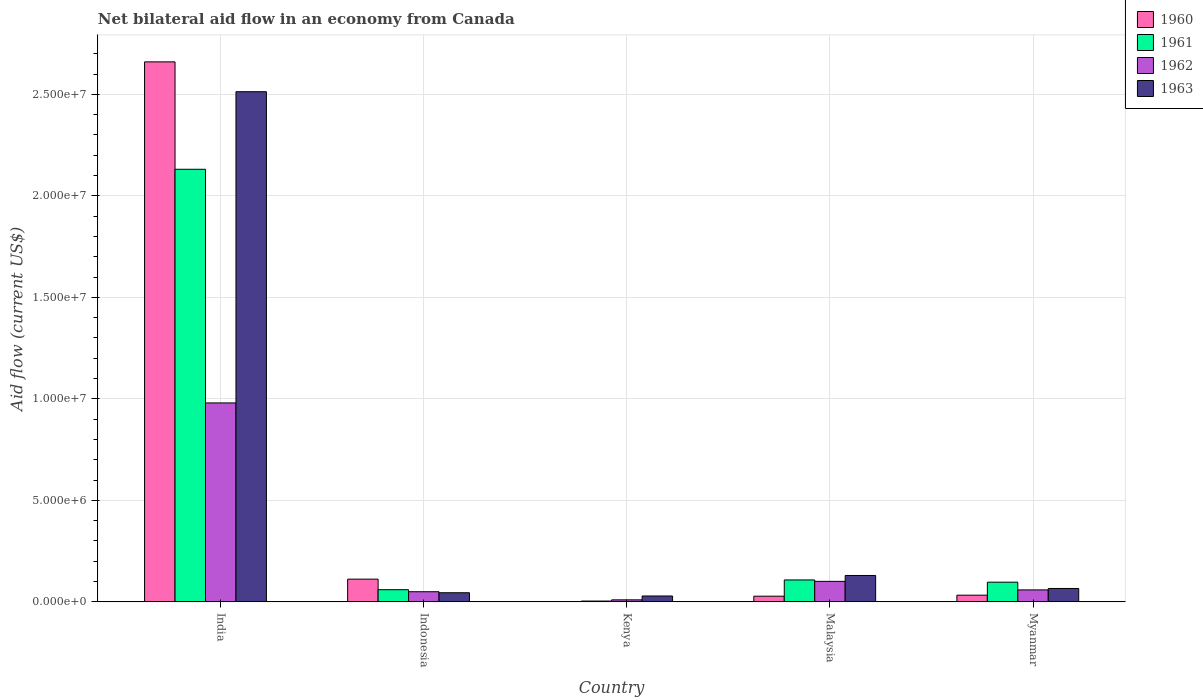How many different coloured bars are there?
Your response must be concise. 4. How many groups of bars are there?
Ensure brevity in your answer.  5. Are the number of bars per tick equal to the number of legend labels?
Offer a very short reply. Yes. Are the number of bars on each tick of the X-axis equal?
Provide a short and direct response. Yes. What is the label of the 5th group of bars from the left?
Your answer should be compact. Myanmar. What is the net bilateral aid flow in 1961 in India?
Provide a short and direct response. 2.13e+07. Across all countries, what is the maximum net bilateral aid flow in 1963?
Ensure brevity in your answer.  2.51e+07. In which country was the net bilateral aid flow in 1962 maximum?
Keep it short and to the point. India. In which country was the net bilateral aid flow in 1963 minimum?
Provide a short and direct response. Kenya. What is the total net bilateral aid flow in 1963 in the graph?
Ensure brevity in your answer.  2.78e+07. What is the difference between the net bilateral aid flow in 1963 in Kenya and the net bilateral aid flow in 1962 in Malaysia?
Your response must be concise. -7.20e+05. What is the average net bilateral aid flow in 1961 per country?
Make the answer very short. 4.80e+06. What is the difference between the net bilateral aid flow of/in 1960 and net bilateral aid flow of/in 1961 in Indonesia?
Make the answer very short. 5.20e+05. What is the ratio of the net bilateral aid flow in 1960 in Malaysia to that in Myanmar?
Make the answer very short. 0.85. Is the net bilateral aid flow in 1962 in Malaysia less than that in Myanmar?
Give a very brief answer. No. What is the difference between the highest and the second highest net bilateral aid flow in 1963?
Provide a short and direct response. 2.38e+07. What is the difference between the highest and the lowest net bilateral aid flow in 1962?
Ensure brevity in your answer.  9.70e+06. In how many countries, is the net bilateral aid flow in 1960 greater than the average net bilateral aid flow in 1960 taken over all countries?
Keep it short and to the point. 1. Is it the case that in every country, the sum of the net bilateral aid flow in 1960 and net bilateral aid flow in 1962 is greater than the sum of net bilateral aid flow in 1963 and net bilateral aid flow in 1961?
Your answer should be very brief. No. What does the 4th bar from the left in Malaysia represents?
Offer a terse response. 1963. Is it the case that in every country, the sum of the net bilateral aid flow in 1963 and net bilateral aid flow in 1961 is greater than the net bilateral aid flow in 1962?
Your answer should be very brief. Yes. Are all the bars in the graph horizontal?
Your answer should be compact. No. How many countries are there in the graph?
Make the answer very short. 5. What is the difference between two consecutive major ticks on the Y-axis?
Give a very brief answer. 5.00e+06. Are the values on the major ticks of Y-axis written in scientific E-notation?
Offer a very short reply. Yes. Does the graph contain any zero values?
Offer a very short reply. No. Where does the legend appear in the graph?
Offer a terse response. Top right. How many legend labels are there?
Offer a very short reply. 4. What is the title of the graph?
Make the answer very short. Net bilateral aid flow in an economy from Canada. What is the label or title of the X-axis?
Provide a succinct answer. Country. What is the label or title of the Y-axis?
Provide a succinct answer. Aid flow (current US$). What is the Aid flow (current US$) in 1960 in India?
Your answer should be very brief. 2.66e+07. What is the Aid flow (current US$) in 1961 in India?
Offer a terse response. 2.13e+07. What is the Aid flow (current US$) of 1962 in India?
Provide a short and direct response. 9.80e+06. What is the Aid flow (current US$) of 1963 in India?
Ensure brevity in your answer.  2.51e+07. What is the Aid flow (current US$) in 1960 in Indonesia?
Offer a terse response. 1.12e+06. What is the Aid flow (current US$) of 1963 in Indonesia?
Your response must be concise. 4.50e+05. What is the Aid flow (current US$) of 1962 in Kenya?
Make the answer very short. 1.00e+05. What is the Aid flow (current US$) of 1963 in Kenya?
Offer a very short reply. 2.90e+05. What is the Aid flow (current US$) of 1960 in Malaysia?
Offer a very short reply. 2.80e+05. What is the Aid flow (current US$) of 1961 in Malaysia?
Make the answer very short. 1.08e+06. What is the Aid flow (current US$) of 1962 in Malaysia?
Offer a terse response. 1.01e+06. What is the Aid flow (current US$) of 1963 in Malaysia?
Offer a very short reply. 1.30e+06. What is the Aid flow (current US$) in 1961 in Myanmar?
Make the answer very short. 9.70e+05. What is the Aid flow (current US$) in 1962 in Myanmar?
Offer a terse response. 5.90e+05. What is the Aid flow (current US$) of 1963 in Myanmar?
Provide a succinct answer. 6.60e+05. Across all countries, what is the maximum Aid flow (current US$) of 1960?
Your response must be concise. 2.66e+07. Across all countries, what is the maximum Aid flow (current US$) of 1961?
Your answer should be very brief. 2.13e+07. Across all countries, what is the maximum Aid flow (current US$) of 1962?
Make the answer very short. 9.80e+06. Across all countries, what is the maximum Aid flow (current US$) in 1963?
Make the answer very short. 2.51e+07. Across all countries, what is the minimum Aid flow (current US$) in 1960?
Your answer should be very brief. 10000. Across all countries, what is the minimum Aid flow (current US$) in 1961?
Provide a short and direct response. 4.00e+04. Across all countries, what is the minimum Aid flow (current US$) of 1962?
Offer a very short reply. 1.00e+05. What is the total Aid flow (current US$) of 1960 in the graph?
Your answer should be compact. 2.83e+07. What is the total Aid flow (current US$) in 1961 in the graph?
Provide a succinct answer. 2.40e+07. What is the total Aid flow (current US$) in 1962 in the graph?
Your answer should be compact. 1.20e+07. What is the total Aid flow (current US$) of 1963 in the graph?
Make the answer very short. 2.78e+07. What is the difference between the Aid flow (current US$) in 1960 in India and that in Indonesia?
Your answer should be compact. 2.55e+07. What is the difference between the Aid flow (current US$) in 1961 in India and that in Indonesia?
Provide a succinct answer. 2.07e+07. What is the difference between the Aid flow (current US$) in 1962 in India and that in Indonesia?
Ensure brevity in your answer.  9.30e+06. What is the difference between the Aid flow (current US$) of 1963 in India and that in Indonesia?
Keep it short and to the point. 2.47e+07. What is the difference between the Aid flow (current US$) of 1960 in India and that in Kenya?
Ensure brevity in your answer.  2.66e+07. What is the difference between the Aid flow (current US$) of 1961 in India and that in Kenya?
Your response must be concise. 2.13e+07. What is the difference between the Aid flow (current US$) of 1962 in India and that in Kenya?
Ensure brevity in your answer.  9.70e+06. What is the difference between the Aid flow (current US$) of 1963 in India and that in Kenya?
Your answer should be very brief. 2.48e+07. What is the difference between the Aid flow (current US$) of 1960 in India and that in Malaysia?
Ensure brevity in your answer.  2.63e+07. What is the difference between the Aid flow (current US$) in 1961 in India and that in Malaysia?
Offer a terse response. 2.02e+07. What is the difference between the Aid flow (current US$) in 1962 in India and that in Malaysia?
Give a very brief answer. 8.79e+06. What is the difference between the Aid flow (current US$) in 1963 in India and that in Malaysia?
Ensure brevity in your answer.  2.38e+07. What is the difference between the Aid flow (current US$) in 1960 in India and that in Myanmar?
Offer a very short reply. 2.63e+07. What is the difference between the Aid flow (current US$) of 1961 in India and that in Myanmar?
Provide a short and direct response. 2.03e+07. What is the difference between the Aid flow (current US$) of 1962 in India and that in Myanmar?
Keep it short and to the point. 9.21e+06. What is the difference between the Aid flow (current US$) of 1963 in India and that in Myanmar?
Your response must be concise. 2.45e+07. What is the difference between the Aid flow (current US$) of 1960 in Indonesia and that in Kenya?
Provide a succinct answer. 1.11e+06. What is the difference between the Aid flow (current US$) in 1961 in Indonesia and that in Kenya?
Offer a very short reply. 5.60e+05. What is the difference between the Aid flow (current US$) of 1962 in Indonesia and that in Kenya?
Offer a very short reply. 4.00e+05. What is the difference between the Aid flow (current US$) of 1960 in Indonesia and that in Malaysia?
Provide a succinct answer. 8.40e+05. What is the difference between the Aid flow (current US$) of 1961 in Indonesia and that in Malaysia?
Provide a short and direct response. -4.80e+05. What is the difference between the Aid flow (current US$) in 1962 in Indonesia and that in Malaysia?
Give a very brief answer. -5.10e+05. What is the difference between the Aid flow (current US$) of 1963 in Indonesia and that in Malaysia?
Make the answer very short. -8.50e+05. What is the difference between the Aid flow (current US$) of 1960 in Indonesia and that in Myanmar?
Provide a succinct answer. 7.90e+05. What is the difference between the Aid flow (current US$) in 1961 in Indonesia and that in Myanmar?
Your response must be concise. -3.70e+05. What is the difference between the Aid flow (current US$) of 1962 in Indonesia and that in Myanmar?
Provide a short and direct response. -9.00e+04. What is the difference between the Aid flow (current US$) of 1961 in Kenya and that in Malaysia?
Provide a short and direct response. -1.04e+06. What is the difference between the Aid flow (current US$) in 1962 in Kenya and that in Malaysia?
Your response must be concise. -9.10e+05. What is the difference between the Aid flow (current US$) in 1963 in Kenya and that in Malaysia?
Provide a short and direct response. -1.01e+06. What is the difference between the Aid flow (current US$) in 1960 in Kenya and that in Myanmar?
Your response must be concise. -3.20e+05. What is the difference between the Aid flow (current US$) of 1961 in Kenya and that in Myanmar?
Offer a terse response. -9.30e+05. What is the difference between the Aid flow (current US$) of 1962 in Kenya and that in Myanmar?
Offer a very short reply. -4.90e+05. What is the difference between the Aid flow (current US$) in 1963 in Kenya and that in Myanmar?
Give a very brief answer. -3.70e+05. What is the difference between the Aid flow (current US$) in 1962 in Malaysia and that in Myanmar?
Make the answer very short. 4.20e+05. What is the difference between the Aid flow (current US$) of 1963 in Malaysia and that in Myanmar?
Provide a short and direct response. 6.40e+05. What is the difference between the Aid flow (current US$) of 1960 in India and the Aid flow (current US$) of 1961 in Indonesia?
Ensure brevity in your answer.  2.60e+07. What is the difference between the Aid flow (current US$) of 1960 in India and the Aid flow (current US$) of 1962 in Indonesia?
Give a very brief answer. 2.61e+07. What is the difference between the Aid flow (current US$) of 1960 in India and the Aid flow (current US$) of 1963 in Indonesia?
Offer a very short reply. 2.62e+07. What is the difference between the Aid flow (current US$) of 1961 in India and the Aid flow (current US$) of 1962 in Indonesia?
Provide a succinct answer. 2.08e+07. What is the difference between the Aid flow (current US$) in 1961 in India and the Aid flow (current US$) in 1963 in Indonesia?
Your response must be concise. 2.09e+07. What is the difference between the Aid flow (current US$) in 1962 in India and the Aid flow (current US$) in 1963 in Indonesia?
Your response must be concise. 9.35e+06. What is the difference between the Aid flow (current US$) of 1960 in India and the Aid flow (current US$) of 1961 in Kenya?
Your answer should be compact. 2.66e+07. What is the difference between the Aid flow (current US$) of 1960 in India and the Aid flow (current US$) of 1962 in Kenya?
Give a very brief answer. 2.65e+07. What is the difference between the Aid flow (current US$) in 1960 in India and the Aid flow (current US$) in 1963 in Kenya?
Provide a short and direct response. 2.63e+07. What is the difference between the Aid flow (current US$) of 1961 in India and the Aid flow (current US$) of 1962 in Kenya?
Offer a terse response. 2.12e+07. What is the difference between the Aid flow (current US$) of 1961 in India and the Aid flow (current US$) of 1963 in Kenya?
Give a very brief answer. 2.10e+07. What is the difference between the Aid flow (current US$) in 1962 in India and the Aid flow (current US$) in 1963 in Kenya?
Offer a terse response. 9.51e+06. What is the difference between the Aid flow (current US$) of 1960 in India and the Aid flow (current US$) of 1961 in Malaysia?
Ensure brevity in your answer.  2.55e+07. What is the difference between the Aid flow (current US$) in 1960 in India and the Aid flow (current US$) in 1962 in Malaysia?
Your answer should be very brief. 2.56e+07. What is the difference between the Aid flow (current US$) of 1960 in India and the Aid flow (current US$) of 1963 in Malaysia?
Ensure brevity in your answer.  2.53e+07. What is the difference between the Aid flow (current US$) of 1961 in India and the Aid flow (current US$) of 1962 in Malaysia?
Provide a short and direct response. 2.03e+07. What is the difference between the Aid flow (current US$) of 1961 in India and the Aid flow (current US$) of 1963 in Malaysia?
Provide a short and direct response. 2.00e+07. What is the difference between the Aid flow (current US$) in 1962 in India and the Aid flow (current US$) in 1963 in Malaysia?
Ensure brevity in your answer.  8.50e+06. What is the difference between the Aid flow (current US$) in 1960 in India and the Aid flow (current US$) in 1961 in Myanmar?
Ensure brevity in your answer.  2.56e+07. What is the difference between the Aid flow (current US$) of 1960 in India and the Aid flow (current US$) of 1962 in Myanmar?
Your answer should be compact. 2.60e+07. What is the difference between the Aid flow (current US$) of 1960 in India and the Aid flow (current US$) of 1963 in Myanmar?
Provide a short and direct response. 2.59e+07. What is the difference between the Aid flow (current US$) in 1961 in India and the Aid flow (current US$) in 1962 in Myanmar?
Keep it short and to the point. 2.07e+07. What is the difference between the Aid flow (current US$) in 1961 in India and the Aid flow (current US$) in 1963 in Myanmar?
Keep it short and to the point. 2.06e+07. What is the difference between the Aid flow (current US$) in 1962 in India and the Aid flow (current US$) in 1963 in Myanmar?
Your answer should be very brief. 9.14e+06. What is the difference between the Aid flow (current US$) in 1960 in Indonesia and the Aid flow (current US$) in 1961 in Kenya?
Provide a succinct answer. 1.08e+06. What is the difference between the Aid flow (current US$) in 1960 in Indonesia and the Aid flow (current US$) in 1962 in Kenya?
Make the answer very short. 1.02e+06. What is the difference between the Aid flow (current US$) of 1960 in Indonesia and the Aid flow (current US$) of 1963 in Kenya?
Offer a very short reply. 8.30e+05. What is the difference between the Aid flow (current US$) in 1961 in Indonesia and the Aid flow (current US$) in 1962 in Kenya?
Your response must be concise. 5.00e+05. What is the difference between the Aid flow (current US$) in 1962 in Indonesia and the Aid flow (current US$) in 1963 in Kenya?
Offer a very short reply. 2.10e+05. What is the difference between the Aid flow (current US$) in 1960 in Indonesia and the Aid flow (current US$) in 1962 in Malaysia?
Provide a succinct answer. 1.10e+05. What is the difference between the Aid flow (current US$) in 1961 in Indonesia and the Aid flow (current US$) in 1962 in Malaysia?
Provide a succinct answer. -4.10e+05. What is the difference between the Aid flow (current US$) of 1961 in Indonesia and the Aid flow (current US$) of 1963 in Malaysia?
Ensure brevity in your answer.  -7.00e+05. What is the difference between the Aid flow (current US$) of 1962 in Indonesia and the Aid flow (current US$) of 1963 in Malaysia?
Your response must be concise. -8.00e+05. What is the difference between the Aid flow (current US$) in 1960 in Indonesia and the Aid flow (current US$) in 1961 in Myanmar?
Provide a short and direct response. 1.50e+05. What is the difference between the Aid flow (current US$) in 1960 in Indonesia and the Aid flow (current US$) in 1962 in Myanmar?
Offer a terse response. 5.30e+05. What is the difference between the Aid flow (current US$) of 1962 in Indonesia and the Aid flow (current US$) of 1963 in Myanmar?
Give a very brief answer. -1.60e+05. What is the difference between the Aid flow (current US$) of 1960 in Kenya and the Aid flow (current US$) of 1961 in Malaysia?
Keep it short and to the point. -1.07e+06. What is the difference between the Aid flow (current US$) in 1960 in Kenya and the Aid flow (current US$) in 1963 in Malaysia?
Provide a short and direct response. -1.29e+06. What is the difference between the Aid flow (current US$) of 1961 in Kenya and the Aid flow (current US$) of 1962 in Malaysia?
Ensure brevity in your answer.  -9.70e+05. What is the difference between the Aid flow (current US$) of 1961 in Kenya and the Aid flow (current US$) of 1963 in Malaysia?
Provide a succinct answer. -1.26e+06. What is the difference between the Aid flow (current US$) in 1962 in Kenya and the Aid flow (current US$) in 1963 in Malaysia?
Ensure brevity in your answer.  -1.20e+06. What is the difference between the Aid flow (current US$) in 1960 in Kenya and the Aid flow (current US$) in 1961 in Myanmar?
Provide a short and direct response. -9.60e+05. What is the difference between the Aid flow (current US$) in 1960 in Kenya and the Aid flow (current US$) in 1962 in Myanmar?
Keep it short and to the point. -5.80e+05. What is the difference between the Aid flow (current US$) in 1960 in Kenya and the Aid flow (current US$) in 1963 in Myanmar?
Offer a very short reply. -6.50e+05. What is the difference between the Aid flow (current US$) in 1961 in Kenya and the Aid flow (current US$) in 1962 in Myanmar?
Keep it short and to the point. -5.50e+05. What is the difference between the Aid flow (current US$) of 1961 in Kenya and the Aid flow (current US$) of 1963 in Myanmar?
Give a very brief answer. -6.20e+05. What is the difference between the Aid flow (current US$) of 1962 in Kenya and the Aid flow (current US$) of 1963 in Myanmar?
Your answer should be very brief. -5.60e+05. What is the difference between the Aid flow (current US$) in 1960 in Malaysia and the Aid flow (current US$) in 1961 in Myanmar?
Your answer should be very brief. -6.90e+05. What is the difference between the Aid flow (current US$) in 1960 in Malaysia and the Aid flow (current US$) in 1962 in Myanmar?
Your response must be concise. -3.10e+05. What is the difference between the Aid flow (current US$) in 1960 in Malaysia and the Aid flow (current US$) in 1963 in Myanmar?
Your answer should be compact. -3.80e+05. What is the difference between the Aid flow (current US$) in 1961 in Malaysia and the Aid flow (current US$) in 1963 in Myanmar?
Make the answer very short. 4.20e+05. What is the difference between the Aid flow (current US$) of 1962 in Malaysia and the Aid flow (current US$) of 1963 in Myanmar?
Your response must be concise. 3.50e+05. What is the average Aid flow (current US$) in 1960 per country?
Your answer should be compact. 5.67e+06. What is the average Aid flow (current US$) in 1961 per country?
Make the answer very short. 4.80e+06. What is the average Aid flow (current US$) of 1962 per country?
Provide a succinct answer. 2.40e+06. What is the average Aid flow (current US$) in 1963 per country?
Give a very brief answer. 5.57e+06. What is the difference between the Aid flow (current US$) of 1960 and Aid flow (current US$) of 1961 in India?
Your answer should be compact. 5.29e+06. What is the difference between the Aid flow (current US$) in 1960 and Aid flow (current US$) in 1962 in India?
Provide a succinct answer. 1.68e+07. What is the difference between the Aid flow (current US$) of 1960 and Aid flow (current US$) of 1963 in India?
Offer a very short reply. 1.47e+06. What is the difference between the Aid flow (current US$) of 1961 and Aid flow (current US$) of 1962 in India?
Provide a short and direct response. 1.15e+07. What is the difference between the Aid flow (current US$) of 1961 and Aid flow (current US$) of 1963 in India?
Ensure brevity in your answer.  -3.82e+06. What is the difference between the Aid flow (current US$) in 1962 and Aid flow (current US$) in 1963 in India?
Make the answer very short. -1.53e+07. What is the difference between the Aid flow (current US$) in 1960 and Aid flow (current US$) in 1961 in Indonesia?
Offer a very short reply. 5.20e+05. What is the difference between the Aid flow (current US$) of 1960 and Aid flow (current US$) of 1962 in Indonesia?
Provide a short and direct response. 6.20e+05. What is the difference between the Aid flow (current US$) in 1960 and Aid flow (current US$) in 1963 in Indonesia?
Your response must be concise. 6.70e+05. What is the difference between the Aid flow (current US$) of 1961 and Aid flow (current US$) of 1962 in Indonesia?
Your answer should be very brief. 1.00e+05. What is the difference between the Aid flow (current US$) of 1960 and Aid flow (current US$) of 1961 in Kenya?
Your answer should be compact. -3.00e+04. What is the difference between the Aid flow (current US$) in 1960 and Aid flow (current US$) in 1963 in Kenya?
Give a very brief answer. -2.80e+05. What is the difference between the Aid flow (current US$) of 1962 and Aid flow (current US$) of 1963 in Kenya?
Keep it short and to the point. -1.90e+05. What is the difference between the Aid flow (current US$) of 1960 and Aid flow (current US$) of 1961 in Malaysia?
Your response must be concise. -8.00e+05. What is the difference between the Aid flow (current US$) of 1960 and Aid flow (current US$) of 1962 in Malaysia?
Give a very brief answer. -7.30e+05. What is the difference between the Aid flow (current US$) in 1960 and Aid flow (current US$) in 1963 in Malaysia?
Provide a succinct answer. -1.02e+06. What is the difference between the Aid flow (current US$) of 1961 and Aid flow (current US$) of 1962 in Malaysia?
Provide a succinct answer. 7.00e+04. What is the difference between the Aid flow (current US$) in 1960 and Aid flow (current US$) in 1961 in Myanmar?
Provide a succinct answer. -6.40e+05. What is the difference between the Aid flow (current US$) in 1960 and Aid flow (current US$) in 1963 in Myanmar?
Your answer should be very brief. -3.30e+05. What is the difference between the Aid flow (current US$) in 1962 and Aid flow (current US$) in 1963 in Myanmar?
Your answer should be very brief. -7.00e+04. What is the ratio of the Aid flow (current US$) of 1960 in India to that in Indonesia?
Keep it short and to the point. 23.75. What is the ratio of the Aid flow (current US$) in 1961 in India to that in Indonesia?
Offer a very short reply. 35.52. What is the ratio of the Aid flow (current US$) in 1962 in India to that in Indonesia?
Make the answer very short. 19.6. What is the ratio of the Aid flow (current US$) of 1963 in India to that in Indonesia?
Make the answer very short. 55.84. What is the ratio of the Aid flow (current US$) in 1960 in India to that in Kenya?
Ensure brevity in your answer.  2660. What is the ratio of the Aid flow (current US$) in 1961 in India to that in Kenya?
Offer a terse response. 532.75. What is the ratio of the Aid flow (current US$) of 1962 in India to that in Kenya?
Give a very brief answer. 98. What is the ratio of the Aid flow (current US$) of 1963 in India to that in Kenya?
Give a very brief answer. 86.66. What is the ratio of the Aid flow (current US$) in 1960 in India to that in Malaysia?
Keep it short and to the point. 95. What is the ratio of the Aid flow (current US$) in 1961 in India to that in Malaysia?
Offer a terse response. 19.73. What is the ratio of the Aid flow (current US$) in 1962 in India to that in Malaysia?
Offer a terse response. 9.7. What is the ratio of the Aid flow (current US$) in 1963 in India to that in Malaysia?
Give a very brief answer. 19.33. What is the ratio of the Aid flow (current US$) in 1960 in India to that in Myanmar?
Give a very brief answer. 80.61. What is the ratio of the Aid flow (current US$) in 1961 in India to that in Myanmar?
Provide a short and direct response. 21.97. What is the ratio of the Aid flow (current US$) of 1962 in India to that in Myanmar?
Offer a very short reply. 16.61. What is the ratio of the Aid flow (current US$) of 1963 in India to that in Myanmar?
Keep it short and to the point. 38.08. What is the ratio of the Aid flow (current US$) in 1960 in Indonesia to that in Kenya?
Offer a terse response. 112. What is the ratio of the Aid flow (current US$) of 1961 in Indonesia to that in Kenya?
Ensure brevity in your answer.  15. What is the ratio of the Aid flow (current US$) of 1963 in Indonesia to that in Kenya?
Your answer should be very brief. 1.55. What is the ratio of the Aid flow (current US$) of 1961 in Indonesia to that in Malaysia?
Keep it short and to the point. 0.56. What is the ratio of the Aid flow (current US$) in 1962 in Indonesia to that in Malaysia?
Your answer should be very brief. 0.49. What is the ratio of the Aid flow (current US$) of 1963 in Indonesia to that in Malaysia?
Give a very brief answer. 0.35. What is the ratio of the Aid flow (current US$) of 1960 in Indonesia to that in Myanmar?
Your answer should be very brief. 3.39. What is the ratio of the Aid flow (current US$) of 1961 in Indonesia to that in Myanmar?
Provide a succinct answer. 0.62. What is the ratio of the Aid flow (current US$) in 1962 in Indonesia to that in Myanmar?
Offer a very short reply. 0.85. What is the ratio of the Aid flow (current US$) in 1963 in Indonesia to that in Myanmar?
Offer a terse response. 0.68. What is the ratio of the Aid flow (current US$) of 1960 in Kenya to that in Malaysia?
Make the answer very short. 0.04. What is the ratio of the Aid flow (current US$) of 1961 in Kenya to that in Malaysia?
Make the answer very short. 0.04. What is the ratio of the Aid flow (current US$) in 1962 in Kenya to that in Malaysia?
Your response must be concise. 0.1. What is the ratio of the Aid flow (current US$) in 1963 in Kenya to that in Malaysia?
Offer a terse response. 0.22. What is the ratio of the Aid flow (current US$) of 1960 in Kenya to that in Myanmar?
Your answer should be very brief. 0.03. What is the ratio of the Aid flow (current US$) of 1961 in Kenya to that in Myanmar?
Provide a short and direct response. 0.04. What is the ratio of the Aid flow (current US$) in 1962 in Kenya to that in Myanmar?
Your answer should be compact. 0.17. What is the ratio of the Aid flow (current US$) of 1963 in Kenya to that in Myanmar?
Your answer should be very brief. 0.44. What is the ratio of the Aid flow (current US$) in 1960 in Malaysia to that in Myanmar?
Your response must be concise. 0.85. What is the ratio of the Aid flow (current US$) of 1961 in Malaysia to that in Myanmar?
Provide a succinct answer. 1.11. What is the ratio of the Aid flow (current US$) in 1962 in Malaysia to that in Myanmar?
Ensure brevity in your answer.  1.71. What is the ratio of the Aid flow (current US$) of 1963 in Malaysia to that in Myanmar?
Provide a short and direct response. 1.97. What is the difference between the highest and the second highest Aid flow (current US$) in 1960?
Your answer should be very brief. 2.55e+07. What is the difference between the highest and the second highest Aid flow (current US$) in 1961?
Keep it short and to the point. 2.02e+07. What is the difference between the highest and the second highest Aid flow (current US$) in 1962?
Keep it short and to the point. 8.79e+06. What is the difference between the highest and the second highest Aid flow (current US$) in 1963?
Give a very brief answer. 2.38e+07. What is the difference between the highest and the lowest Aid flow (current US$) in 1960?
Keep it short and to the point. 2.66e+07. What is the difference between the highest and the lowest Aid flow (current US$) in 1961?
Give a very brief answer. 2.13e+07. What is the difference between the highest and the lowest Aid flow (current US$) of 1962?
Give a very brief answer. 9.70e+06. What is the difference between the highest and the lowest Aid flow (current US$) in 1963?
Your answer should be compact. 2.48e+07. 